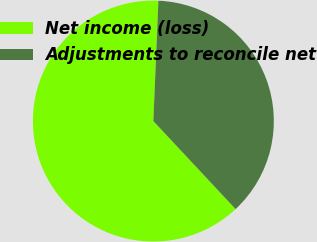<chart> <loc_0><loc_0><loc_500><loc_500><pie_chart><fcel>Net income (loss)<fcel>Adjustments to reconcile net<nl><fcel>62.63%<fcel>37.37%<nl></chart> 